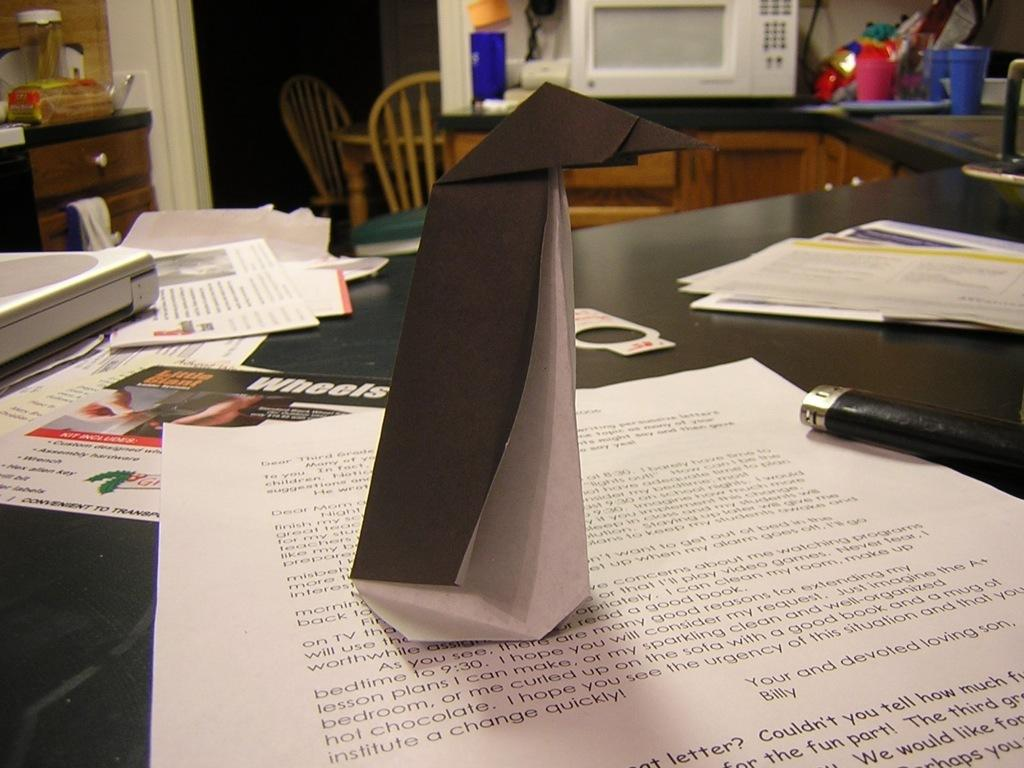What is placed on the black color surface in the image? There are papers on a black color surface in the image. Are there any other objects on the black color surface? Yes, there are other objects on the black color surface. What can be seen in the background of the image? In the background of the image, there is a wooden cupboard, a chair, a microwave, and a few more objects. What advice is being given in the image? There is no indication of any advice being given in the image; it primarily features papers and other objects on a black color surface. 